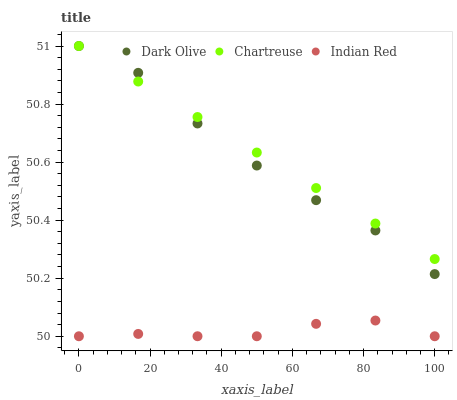Does Indian Red have the minimum area under the curve?
Answer yes or no. Yes. Does Chartreuse have the maximum area under the curve?
Answer yes or no. Yes. Does Dark Olive have the minimum area under the curve?
Answer yes or no. No. Does Dark Olive have the maximum area under the curve?
Answer yes or no. No. Is Chartreuse the smoothest?
Answer yes or no. Yes. Is Dark Olive the roughest?
Answer yes or no. Yes. Is Indian Red the smoothest?
Answer yes or no. No. Is Indian Red the roughest?
Answer yes or no. No. Does Indian Red have the lowest value?
Answer yes or no. Yes. Does Dark Olive have the lowest value?
Answer yes or no. No. Does Dark Olive have the highest value?
Answer yes or no. Yes. Does Indian Red have the highest value?
Answer yes or no. No. Is Indian Red less than Dark Olive?
Answer yes or no. Yes. Is Dark Olive greater than Indian Red?
Answer yes or no. Yes. Does Chartreuse intersect Dark Olive?
Answer yes or no. Yes. Is Chartreuse less than Dark Olive?
Answer yes or no. No. Is Chartreuse greater than Dark Olive?
Answer yes or no. No. Does Indian Red intersect Dark Olive?
Answer yes or no. No. 